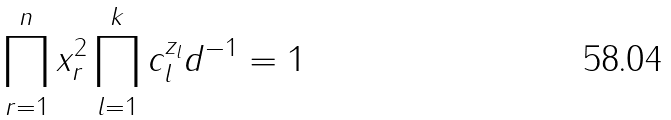Convert formula to latex. <formula><loc_0><loc_0><loc_500><loc_500>\prod _ { r = 1 } ^ { n } x _ { r } ^ { 2 } \prod _ { l = 1 } ^ { k } c _ { l } ^ { z _ { l } } d ^ { - 1 } = 1</formula> 